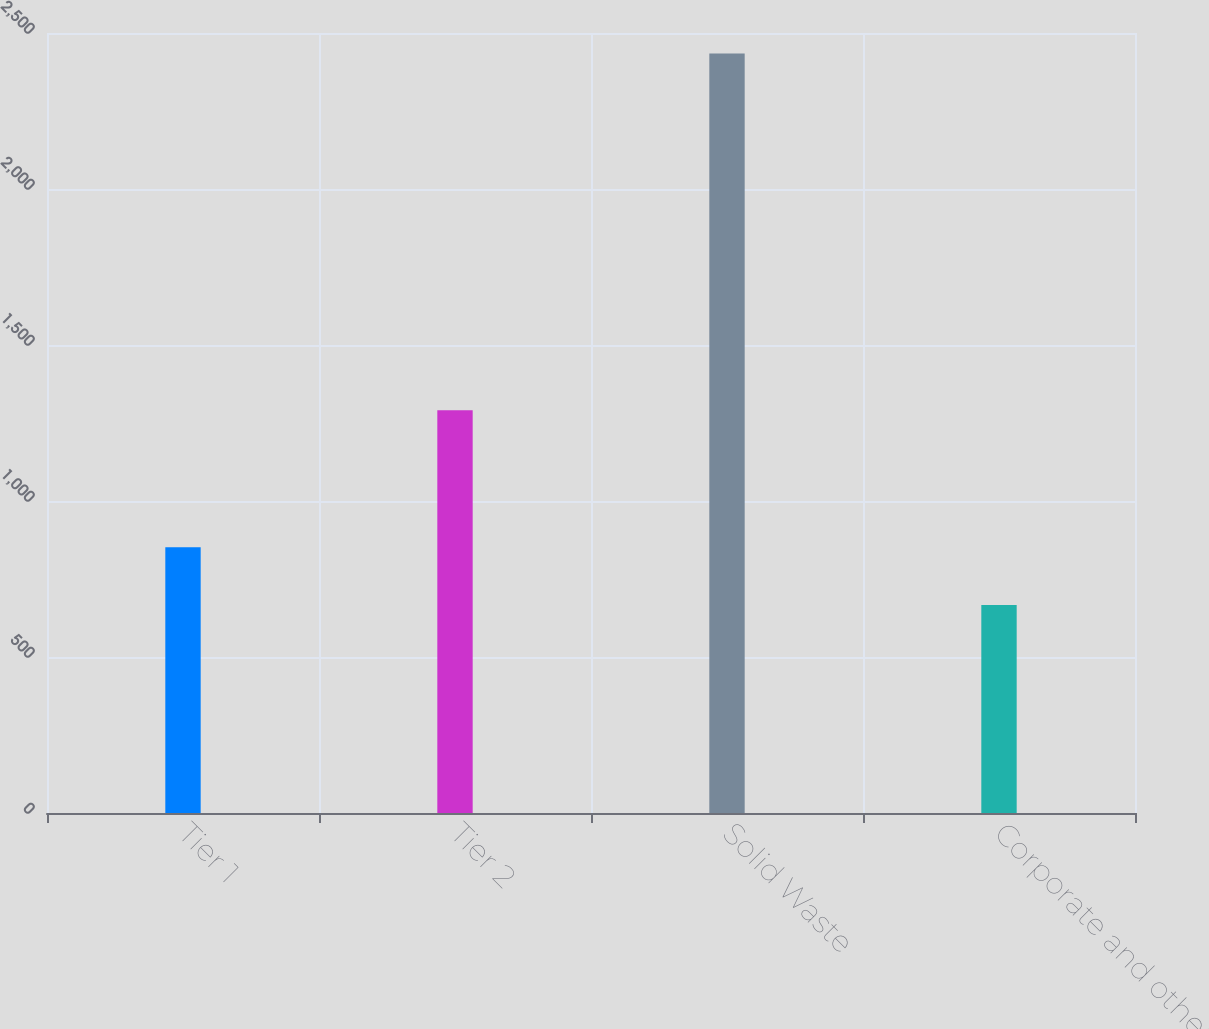Convert chart. <chart><loc_0><loc_0><loc_500><loc_500><bar_chart><fcel>Tier 1<fcel>Tier 2<fcel>Solid Waste<fcel>Corporate and other<nl><fcel>852<fcel>1291<fcel>2434<fcel>667<nl></chart> 